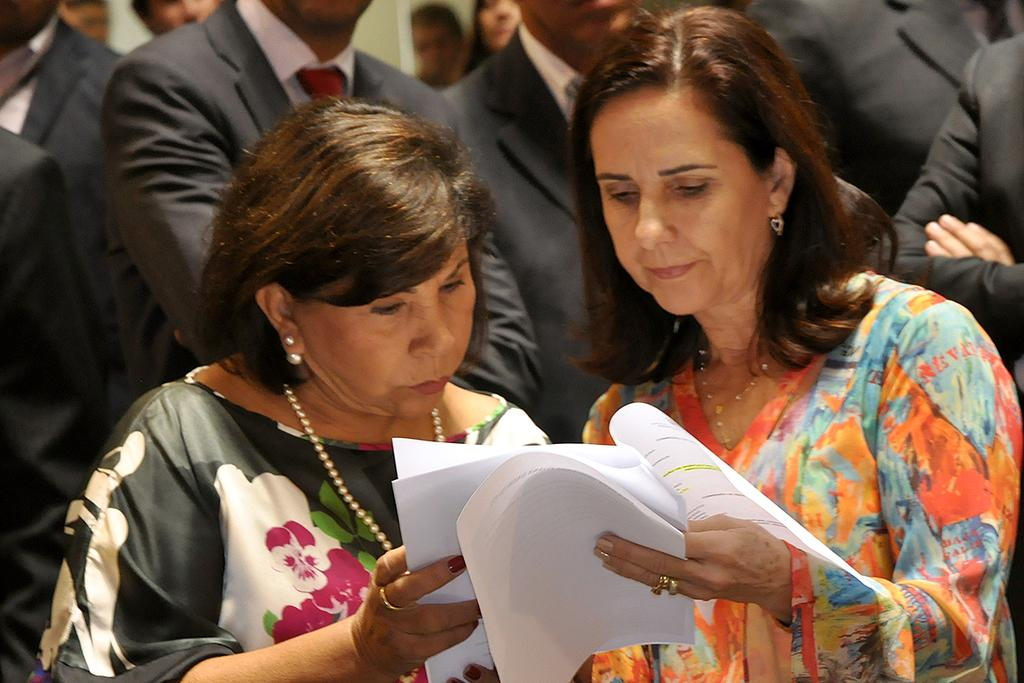How many people are in the image? There is a group of people in the image. Can you describe what the two women are holding? Two women are holding papers in the image. What type of doctor can be seen in the image? There is no doctor present in the image. How many drops of water are visible on the papers held by the women? There is no mention of water or drops in the image, so it cannot be determined. 